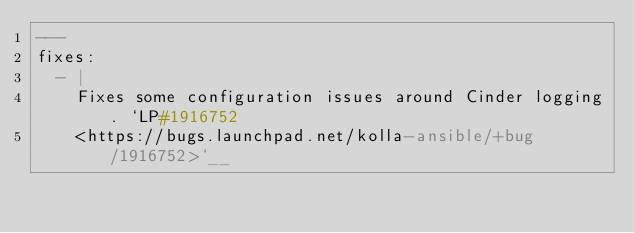Convert code to text. <code><loc_0><loc_0><loc_500><loc_500><_YAML_>---
fixes:
  - |
    Fixes some configuration issues around Cinder logging. `LP#1916752
    <https://bugs.launchpad.net/kolla-ansible/+bug/1916752>`__
</code> 